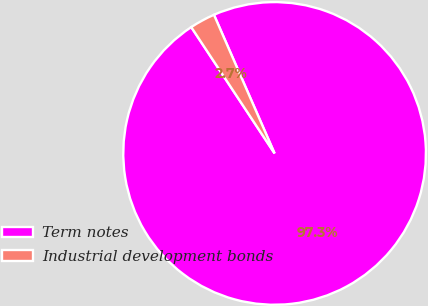Convert chart to OTSL. <chart><loc_0><loc_0><loc_500><loc_500><pie_chart><fcel>Term notes<fcel>Industrial development bonds<nl><fcel>97.28%<fcel>2.72%<nl></chart> 